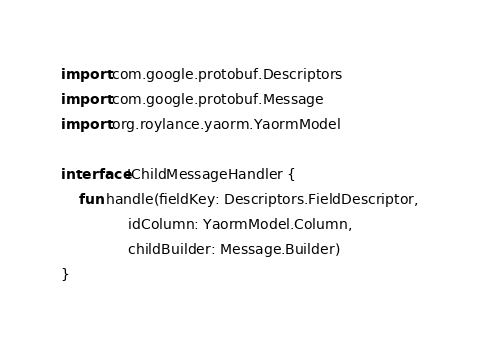<code> <loc_0><loc_0><loc_500><loc_500><_Kotlin_>import com.google.protobuf.Descriptors
import com.google.protobuf.Message
import org.roylance.yaorm.YaormModel

interface IChildMessageHandler {
    fun handle(fieldKey: Descriptors.FieldDescriptor,
               idColumn: YaormModel.Column,
               childBuilder: Message.Builder)
}</code> 